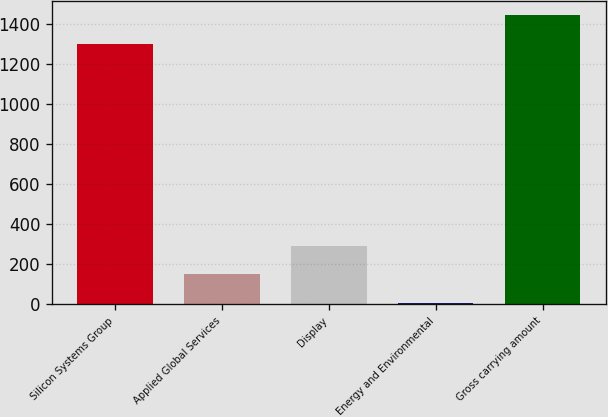Convert chart to OTSL. <chart><loc_0><loc_0><loc_500><loc_500><bar_chart><fcel>Silicon Systems Group<fcel>Applied Global Services<fcel>Display<fcel>Energy and Environmental<fcel>Gross carrying amount<nl><fcel>1301<fcel>148.9<fcel>292.8<fcel>5<fcel>1444.9<nl></chart> 